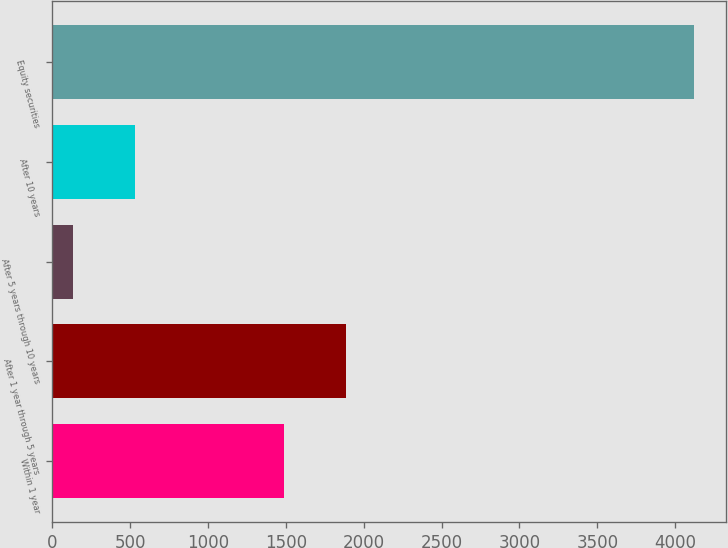Convert chart. <chart><loc_0><loc_0><loc_500><loc_500><bar_chart><fcel>Within 1 year<fcel>After 1 year through 5 years<fcel>After 5 years through 10 years<fcel>After 10 years<fcel>Equity securities<nl><fcel>1489<fcel>1888.1<fcel>130<fcel>529.1<fcel>4121<nl></chart> 